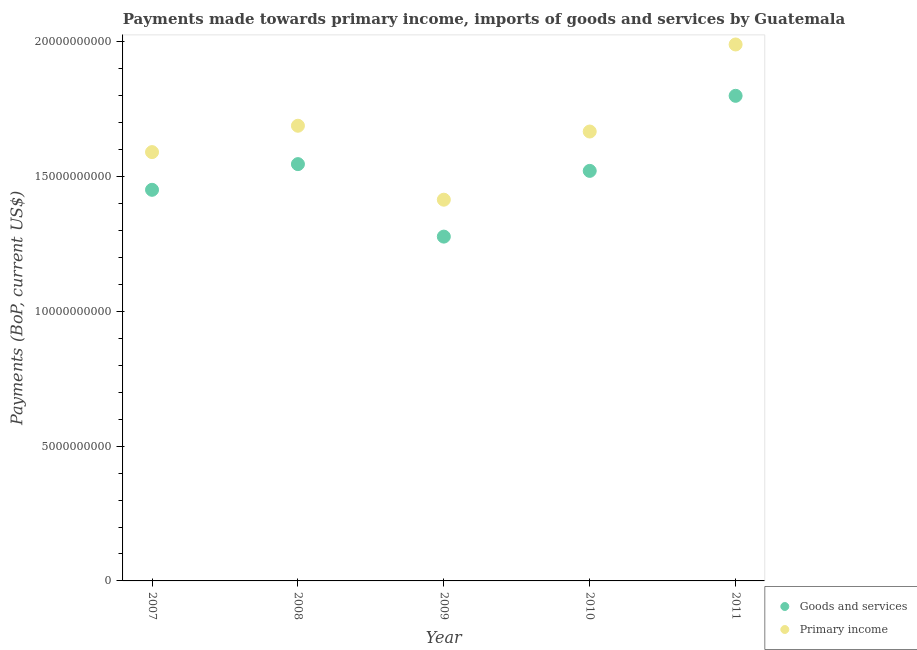What is the payments made towards goods and services in 2011?
Give a very brief answer. 1.80e+1. Across all years, what is the maximum payments made towards primary income?
Your answer should be very brief. 1.99e+1. Across all years, what is the minimum payments made towards primary income?
Make the answer very short. 1.41e+1. In which year was the payments made towards primary income minimum?
Ensure brevity in your answer.  2009. What is the total payments made towards goods and services in the graph?
Offer a terse response. 7.60e+1. What is the difference between the payments made towards goods and services in 2007 and that in 2010?
Provide a succinct answer. -7.02e+08. What is the difference between the payments made towards goods and services in 2007 and the payments made towards primary income in 2009?
Provide a succinct answer. 3.67e+08. What is the average payments made towards goods and services per year?
Ensure brevity in your answer.  1.52e+1. In the year 2009, what is the difference between the payments made towards goods and services and payments made towards primary income?
Keep it short and to the point. -1.37e+09. In how many years, is the payments made towards primary income greater than 6000000000 US$?
Your answer should be very brief. 5. What is the ratio of the payments made towards primary income in 2009 to that in 2011?
Ensure brevity in your answer.  0.71. Is the payments made towards goods and services in 2009 less than that in 2010?
Keep it short and to the point. Yes. What is the difference between the highest and the second highest payments made towards goods and services?
Your answer should be compact. 2.53e+09. What is the difference between the highest and the lowest payments made towards primary income?
Make the answer very short. 5.76e+09. Is the sum of the payments made towards goods and services in 2008 and 2009 greater than the maximum payments made towards primary income across all years?
Provide a succinct answer. Yes. Does the payments made towards goods and services monotonically increase over the years?
Make the answer very short. No. Is the payments made towards goods and services strictly less than the payments made towards primary income over the years?
Ensure brevity in your answer.  Yes. How many years are there in the graph?
Your answer should be very brief. 5. Are the values on the major ticks of Y-axis written in scientific E-notation?
Your answer should be very brief. No. Does the graph contain grids?
Your response must be concise. No. Where does the legend appear in the graph?
Provide a succinct answer. Bottom right. How many legend labels are there?
Give a very brief answer. 2. How are the legend labels stacked?
Your answer should be very brief. Vertical. What is the title of the graph?
Provide a succinct answer. Payments made towards primary income, imports of goods and services by Guatemala. What is the label or title of the X-axis?
Offer a terse response. Year. What is the label or title of the Y-axis?
Ensure brevity in your answer.  Payments (BoP, current US$). What is the Payments (BoP, current US$) in Goods and services in 2007?
Your answer should be compact. 1.45e+1. What is the Payments (BoP, current US$) of Primary income in 2007?
Ensure brevity in your answer.  1.59e+1. What is the Payments (BoP, current US$) of Goods and services in 2008?
Make the answer very short. 1.55e+1. What is the Payments (BoP, current US$) of Primary income in 2008?
Your answer should be very brief. 1.69e+1. What is the Payments (BoP, current US$) of Goods and services in 2009?
Provide a short and direct response. 1.28e+1. What is the Payments (BoP, current US$) in Primary income in 2009?
Give a very brief answer. 1.41e+1. What is the Payments (BoP, current US$) in Goods and services in 2010?
Provide a succinct answer. 1.52e+1. What is the Payments (BoP, current US$) in Primary income in 2010?
Your response must be concise. 1.67e+1. What is the Payments (BoP, current US$) of Goods and services in 2011?
Ensure brevity in your answer.  1.80e+1. What is the Payments (BoP, current US$) in Primary income in 2011?
Offer a terse response. 1.99e+1. Across all years, what is the maximum Payments (BoP, current US$) of Goods and services?
Your answer should be compact. 1.80e+1. Across all years, what is the maximum Payments (BoP, current US$) of Primary income?
Your answer should be very brief. 1.99e+1. Across all years, what is the minimum Payments (BoP, current US$) in Goods and services?
Make the answer very short. 1.28e+1. Across all years, what is the minimum Payments (BoP, current US$) of Primary income?
Make the answer very short. 1.41e+1. What is the total Payments (BoP, current US$) in Goods and services in the graph?
Give a very brief answer. 7.60e+1. What is the total Payments (BoP, current US$) in Primary income in the graph?
Ensure brevity in your answer.  8.35e+1. What is the difference between the Payments (BoP, current US$) in Goods and services in 2007 and that in 2008?
Ensure brevity in your answer.  -9.53e+08. What is the difference between the Payments (BoP, current US$) in Primary income in 2007 and that in 2008?
Ensure brevity in your answer.  -9.78e+08. What is the difference between the Payments (BoP, current US$) of Goods and services in 2007 and that in 2009?
Provide a short and direct response. 1.74e+09. What is the difference between the Payments (BoP, current US$) of Primary income in 2007 and that in 2009?
Provide a succinct answer. 1.77e+09. What is the difference between the Payments (BoP, current US$) of Goods and services in 2007 and that in 2010?
Keep it short and to the point. -7.02e+08. What is the difference between the Payments (BoP, current US$) of Primary income in 2007 and that in 2010?
Give a very brief answer. -7.64e+08. What is the difference between the Payments (BoP, current US$) of Goods and services in 2007 and that in 2011?
Provide a short and direct response. -3.49e+09. What is the difference between the Payments (BoP, current US$) of Primary income in 2007 and that in 2011?
Give a very brief answer. -3.99e+09. What is the difference between the Payments (BoP, current US$) in Goods and services in 2008 and that in 2009?
Offer a terse response. 2.69e+09. What is the difference between the Payments (BoP, current US$) in Primary income in 2008 and that in 2009?
Provide a short and direct response. 2.74e+09. What is the difference between the Payments (BoP, current US$) in Goods and services in 2008 and that in 2010?
Your answer should be compact. 2.51e+08. What is the difference between the Payments (BoP, current US$) in Primary income in 2008 and that in 2010?
Your answer should be very brief. 2.14e+08. What is the difference between the Payments (BoP, current US$) in Goods and services in 2008 and that in 2011?
Give a very brief answer. -2.53e+09. What is the difference between the Payments (BoP, current US$) in Primary income in 2008 and that in 2011?
Your response must be concise. -3.02e+09. What is the difference between the Payments (BoP, current US$) in Goods and services in 2009 and that in 2010?
Provide a short and direct response. -2.44e+09. What is the difference between the Payments (BoP, current US$) in Primary income in 2009 and that in 2010?
Your answer should be compact. -2.53e+09. What is the difference between the Payments (BoP, current US$) of Goods and services in 2009 and that in 2011?
Give a very brief answer. -5.22e+09. What is the difference between the Payments (BoP, current US$) in Primary income in 2009 and that in 2011?
Your response must be concise. -5.76e+09. What is the difference between the Payments (BoP, current US$) of Goods and services in 2010 and that in 2011?
Offer a terse response. -2.79e+09. What is the difference between the Payments (BoP, current US$) of Primary income in 2010 and that in 2011?
Provide a succinct answer. -3.23e+09. What is the difference between the Payments (BoP, current US$) in Goods and services in 2007 and the Payments (BoP, current US$) in Primary income in 2008?
Provide a short and direct response. -2.38e+09. What is the difference between the Payments (BoP, current US$) of Goods and services in 2007 and the Payments (BoP, current US$) of Primary income in 2009?
Offer a very short reply. 3.67e+08. What is the difference between the Payments (BoP, current US$) in Goods and services in 2007 and the Payments (BoP, current US$) in Primary income in 2010?
Ensure brevity in your answer.  -2.16e+09. What is the difference between the Payments (BoP, current US$) in Goods and services in 2007 and the Payments (BoP, current US$) in Primary income in 2011?
Keep it short and to the point. -5.39e+09. What is the difference between the Payments (BoP, current US$) of Goods and services in 2008 and the Payments (BoP, current US$) of Primary income in 2009?
Ensure brevity in your answer.  1.32e+09. What is the difference between the Payments (BoP, current US$) in Goods and services in 2008 and the Payments (BoP, current US$) in Primary income in 2010?
Give a very brief answer. -1.21e+09. What is the difference between the Payments (BoP, current US$) of Goods and services in 2008 and the Payments (BoP, current US$) of Primary income in 2011?
Provide a short and direct response. -4.44e+09. What is the difference between the Payments (BoP, current US$) of Goods and services in 2009 and the Payments (BoP, current US$) of Primary income in 2010?
Provide a short and direct response. -3.90e+09. What is the difference between the Payments (BoP, current US$) in Goods and services in 2009 and the Payments (BoP, current US$) in Primary income in 2011?
Provide a short and direct response. -7.13e+09. What is the difference between the Payments (BoP, current US$) in Goods and services in 2010 and the Payments (BoP, current US$) in Primary income in 2011?
Ensure brevity in your answer.  -4.69e+09. What is the average Payments (BoP, current US$) in Goods and services per year?
Your answer should be compact. 1.52e+1. What is the average Payments (BoP, current US$) in Primary income per year?
Your answer should be very brief. 1.67e+1. In the year 2007, what is the difference between the Payments (BoP, current US$) of Goods and services and Payments (BoP, current US$) of Primary income?
Your response must be concise. -1.40e+09. In the year 2008, what is the difference between the Payments (BoP, current US$) of Goods and services and Payments (BoP, current US$) of Primary income?
Keep it short and to the point. -1.42e+09. In the year 2009, what is the difference between the Payments (BoP, current US$) in Goods and services and Payments (BoP, current US$) in Primary income?
Offer a terse response. -1.37e+09. In the year 2010, what is the difference between the Payments (BoP, current US$) of Goods and services and Payments (BoP, current US$) of Primary income?
Give a very brief answer. -1.46e+09. In the year 2011, what is the difference between the Payments (BoP, current US$) in Goods and services and Payments (BoP, current US$) in Primary income?
Provide a succinct answer. -1.90e+09. What is the ratio of the Payments (BoP, current US$) of Goods and services in 2007 to that in 2008?
Offer a very short reply. 0.94. What is the ratio of the Payments (BoP, current US$) of Primary income in 2007 to that in 2008?
Make the answer very short. 0.94. What is the ratio of the Payments (BoP, current US$) of Goods and services in 2007 to that in 2009?
Offer a very short reply. 1.14. What is the ratio of the Payments (BoP, current US$) of Primary income in 2007 to that in 2009?
Offer a terse response. 1.12. What is the ratio of the Payments (BoP, current US$) of Goods and services in 2007 to that in 2010?
Provide a succinct answer. 0.95. What is the ratio of the Payments (BoP, current US$) of Primary income in 2007 to that in 2010?
Keep it short and to the point. 0.95. What is the ratio of the Payments (BoP, current US$) of Goods and services in 2007 to that in 2011?
Provide a short and direct response. 0.81. What is the ratio of the Payments (BoP, current US$) in Primary income in 2007 to that in 2011?
Provide a succinct answer. 0.8. What is the ratio of the Payments (BoP, current US$) of Goods and services in 2008 to that in 2009?
Give a very brief answer. 1.21. What is the ratio of the Payments (BoP, current US$) in Primary income in 2008 to that in 2009?
Your answer should be very brief. 1.19. What is the ratio of the Payments (BoP, current US$) in Goods and services in 2008 to that in 2010?
Provide a short and direct response. 1.02. What is the ratio of the Payments (BoP, current US$) of Primary income in 2008 to that in 2010?
Your answer should be compact. 1.01. What is the ratio of the Payments (BoP, current US$) in Goods and services in 2008 to that in 2011?
Give a very brief answer. 0.86. What is the ratio of the Payments (BoP, current US$) in Primary income in 2008 to that in 2011?
Provide a succinct answer. 0.85. What is the ratio of the Payments (BoP, current US$) of Goods and services in 2009 to that in 2010?
Your answer should be compact. 0.84. What is the ratio of the Payments (BoP, current US$) in Primary income in 2009 to that in 2010?
Keep it short and to the point. 0.85. What is the ratio of the Payments (BoP, current US$) of Goods and services in 2009 to that in 2011?
Make the answer very short. 0.71. What is the ratio of the Payments (BoP, current US$) in Primary income in 2009 to that in 2011?
Give a very brief answer. 0.71. What is the ratio of the Payments (BoP, current US$) of Goods and services in 2010 to that in 2011?
Provide a short and direct response. 0.85. What is the ratio of the Payments (BoP, current US$) in Primary income in 2010 to that in 2011?
Give a very brief answer. 0.84. What is the difference between the highest and the second highest Payments (BoP, current US$) of Goods and services?
Your response must be concise. 2.53e+09. What is the difference between the highest and the second highest Payments (BoP, current US$) in Primary income?
Your answer should be very brief. 3.02e+09. What is the difference between the highest and the lowest Payments (BoP, current US$) of Goods and services?
Your answer should be compact. 5.22e+09. What is the difference between the highest and the lowest Payments (BoP, current US$) in Primary income?
Your answer should be compact. 5.76e+09. 